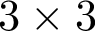Convert formula to latex. <formula><loc_0><loc_0><loc_500><loc_500>3 \times 3</formula> 